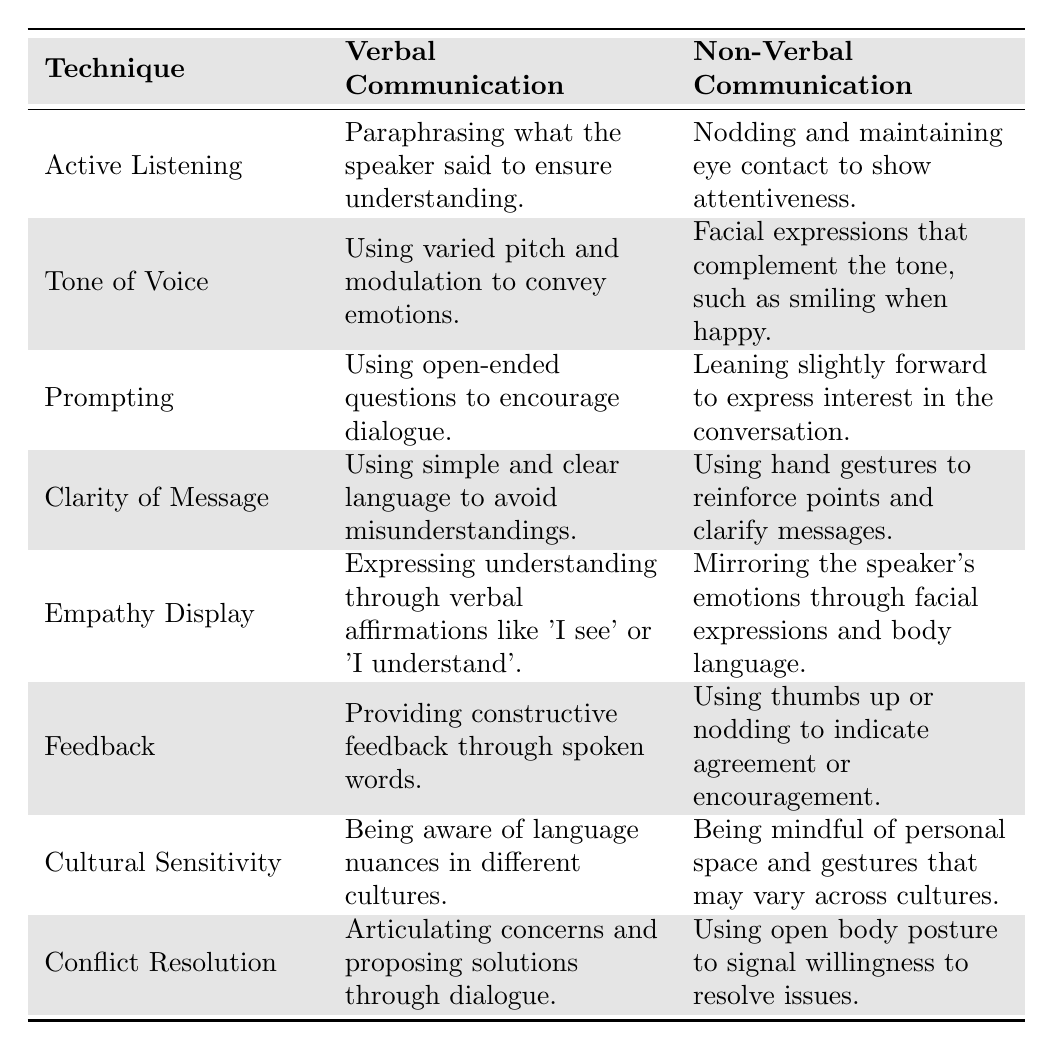What is the verbal communication technique associated with Active Listening? According to the table, the verbal communication technique associated with Active Listening is "Paraphrasing what the speaker said to ensure understanding."
Answer: Paraphrasing what the speaker said to ensure understanding Which technique uses varied pitch and modulation? The technique that uses varied pitch and modulation is "Tone of Voice."
Answer: Tone of Voice Is facial expressions that complement the tone part of Non-Verbal Communication? Yes, the table states that facial expressions that complement the tone, such as smiling when happy, is part of Non-Verbal Communication associated with Tone of Voice.
Answer: Yes How many techniques are listed in the table? There are 8 techniques listed in the table.
Answer: 8 What is the Non-Verbal Communication associated with Empathy Display? The Non-Verbal Communication associated with Empathy Display is "Mirroring the speaker's emotions through facial expressions and body language."
Answer: Mirroring the speaker's emotions through facial expressions and body language Which verbal communication technique involves open-ended questions? The verbal communication technique that involves open-ended questions is "Prompting."
Answer: Prompting Are using hand gestures mentioned as a technique in Clarity of Message? Yes, hand gestures are mentioned in the context of Non-Verbal Communication for Clarity of Message to reinforce points and clarify messages.
Answer: Yes Compare the verbal communication used in Feedback and Active Listening techniques. Feedback involves "Providing constructive feedback through spoken words," while Active Listening involves "Paraphrasing what the speaker said to ensure understanding." Both are different approaches focused on feedback and comprehension.
Answer: Feedback and Active Listening serve different purposes Which two techniques focus on the emotional aspect of communication? The two techniques that focus on the emotional aspect are "Empathy Display" and "Tone of Voice." Empathy Display involves expressing understanding, while Tone of Voice utilizes emotional modulation.
Answer: Empathy Display and Tone of Voice Does the table suggest that cultural sensitivity affects both verbal and non-verbal communication? Yes, the table shows that cultural sensitivity is relevant in both verbal and non-verbal communication, highlighting language nuances and mindful gestures across cultures.
Answer: Yes 